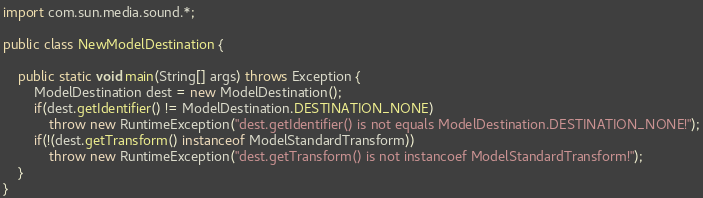Convert code to text. <code><loc_0><loc_0><loc_500><loc_500><_Java_>
import com.sun.media.sound.*;

public class NewModelDestination {

    public static void main(String[] args) throws Exception {
        ModelDestination dest = new ModelDestination();
        if(dest.getIdentifier() != ModelDestination.DESTINATION_NONE)
            throw new RuntimeException("dest.getIdentifier() is not equals ModelDestination.DESTINATION_NONE!");
        if(!(dest.getTransform() instanceof ModelStandardTransform))
            throw new RuntimeException("dest.getTransform() is not instancoef ModelStandardTransform!");
    }
}
</code> 